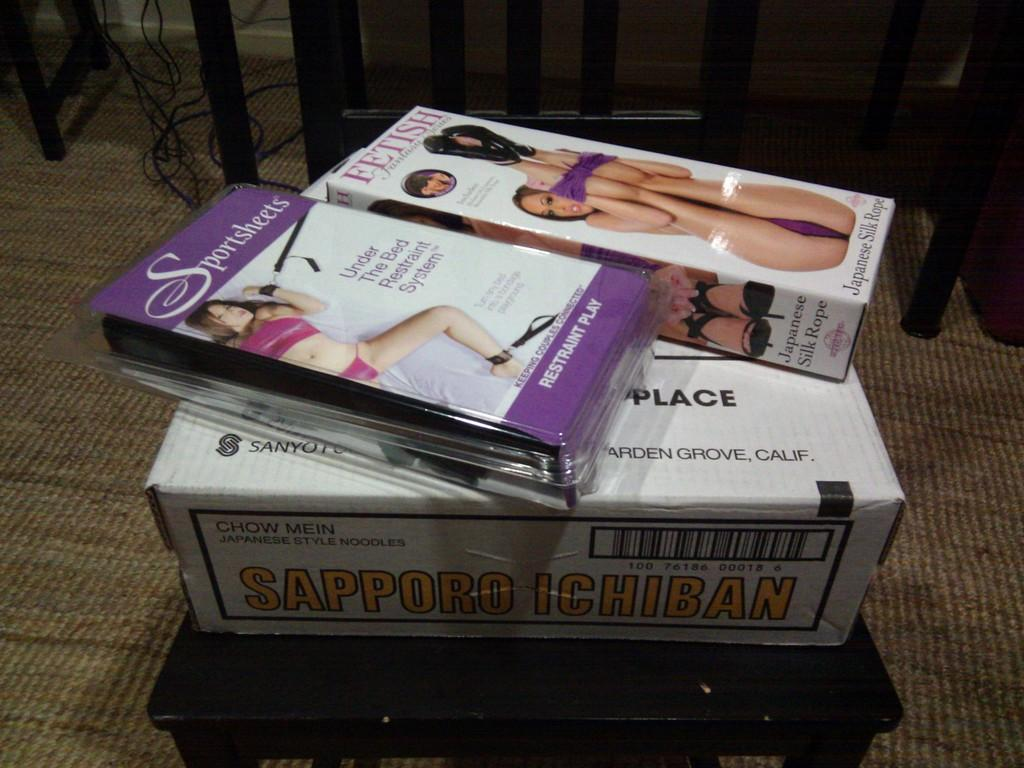<image>
Create a compact narrative representing the image presented. an item with the word fetish at the top of it 